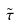Convert formula to latex. <formula><loc_0><loc_0><loc_500><loc_500>\tilde { \tau }</formula> 